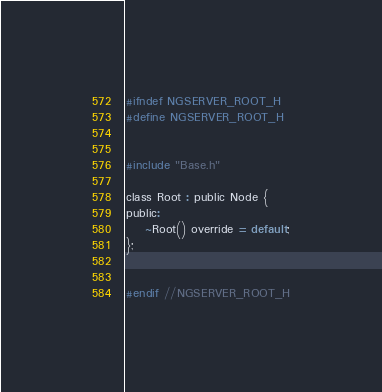Convert code to text. <code><loc_0><loc_0><loc_500><loc_500><_C_>#ifndef NGSERVER_ROOT_H
#define NGSERVER_ROOT_H


#include "Base.h"

class Root : public Node {
public:
    ~Root() override = default;
};


#endif //NGSERVER_ROOT_H
</code> 